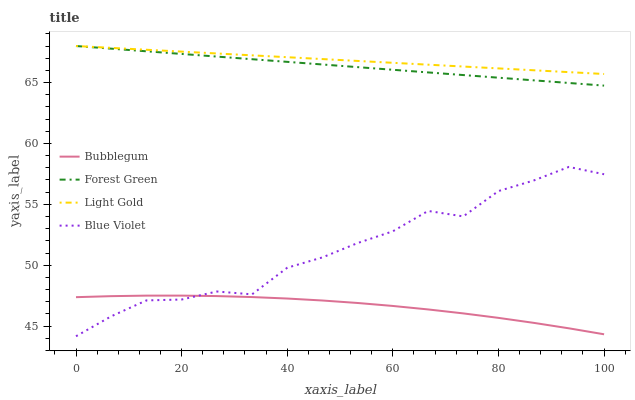Does Blue Violet have the minimum area under the curve?
Answer yes or no. No. Does Blue Violet have the maximum area under the curve?
Answer yes or no. No. Is Blue Violet the smoothest?
Answer yes or no. No. Is Light Gold the roughest?
Answer yes or no. No. Does Light Gold have the lowest value?
Answer yes or no. No. Does Blue Violet have the highest value?
Answer yes or no. No. Is Bubblegum less than Forest Green?
Answer yes or no. Yes. Is Forest Green greater than Blue Violet?
Answer yes or no. Yes. Does Bubblegum intersect Forest Green?
Answer yes or no. No. 